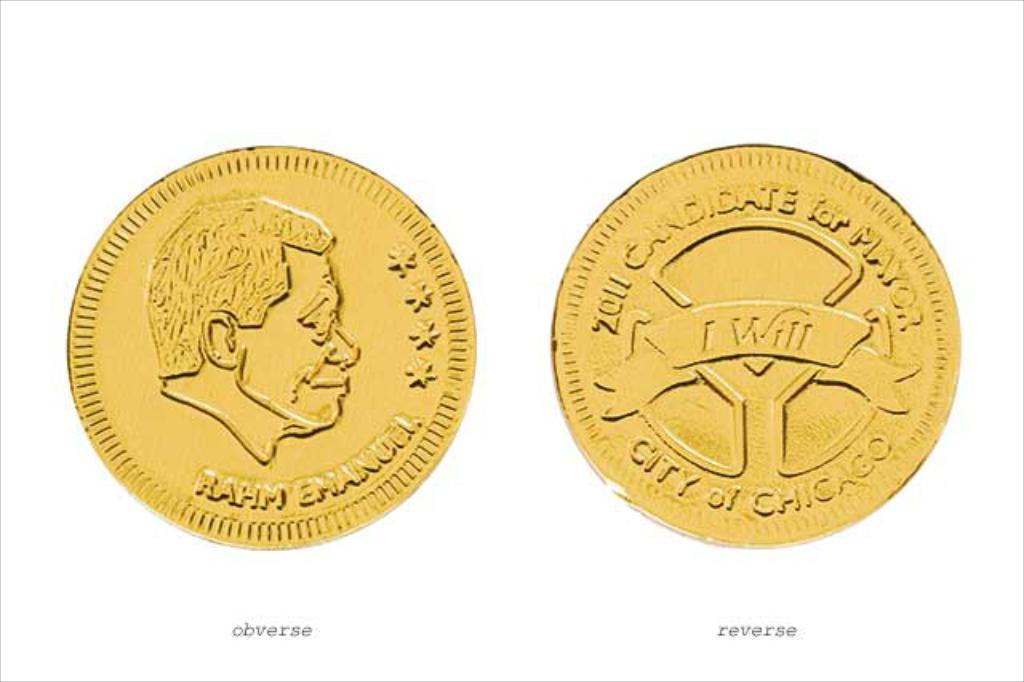<image>
Describe the image concisely. A coin for the 2011 candidate for mayor of Chicago has four stars on the front side. 